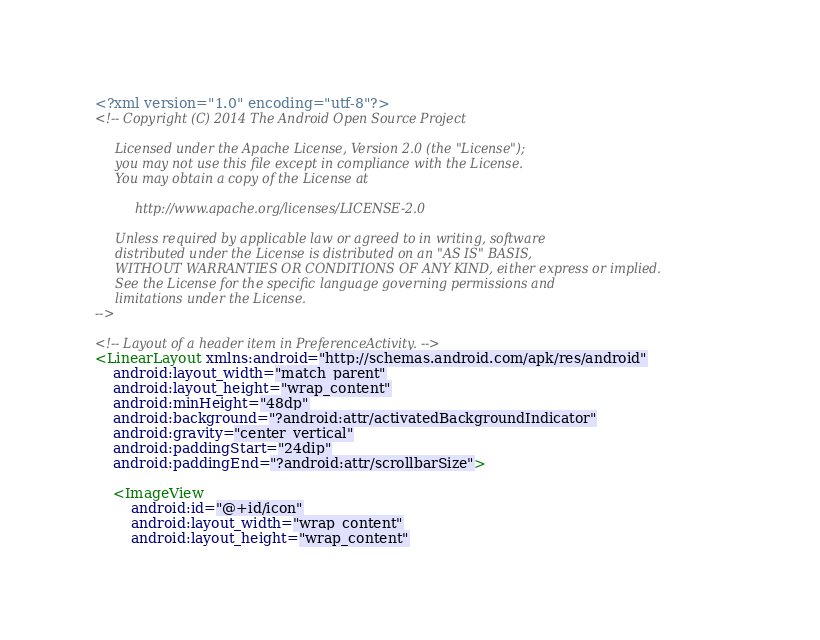<code> <loc_0><loc_0><loc_500><loc_500><_XML_><?xml version="1.0" encoding="utf-8"?>
<!-- Copyright (C) 2014 The Android Open Source Project

     Licensed under the Apache License, Version 2.0 (the "License");
     you may not use this file except in compliance with the License.
     You may obtain a copy of the License at

          http://www.apache.org/licenses/LICENSE-2.0

     Unless required by applicable law or agreed to in writing, software
     distributed under the License is distributed on an "AS IS" BASIS,
     WITHOUT WARRANTIES OR CONDITIONS OF ANY KIND, either express or implied.
     See the License for the specific language governing permissions and
     limitations under the License.
-->

<!-- Layout of a header item in PreferenceActivity. -->
<LinearLayout xmlns:android="http://schemas.android.com/apk/res/android"
    android:layout_width="match_parent"
    android:layout_height="wrap_content"
    android:minHeight="48dp"
    android:background="?android:attr/activatedBackgroundIndicator"
    android:gravity="center_vertical"
    android:paddingStart="24dip"
    android:paddingEnd="?android:attr/scrollbarSize">

    <ImageView
        android:id="@+id/icon"
        android:layout_width="wrap_content"
        android:layout_height="wrap_content"</code> 